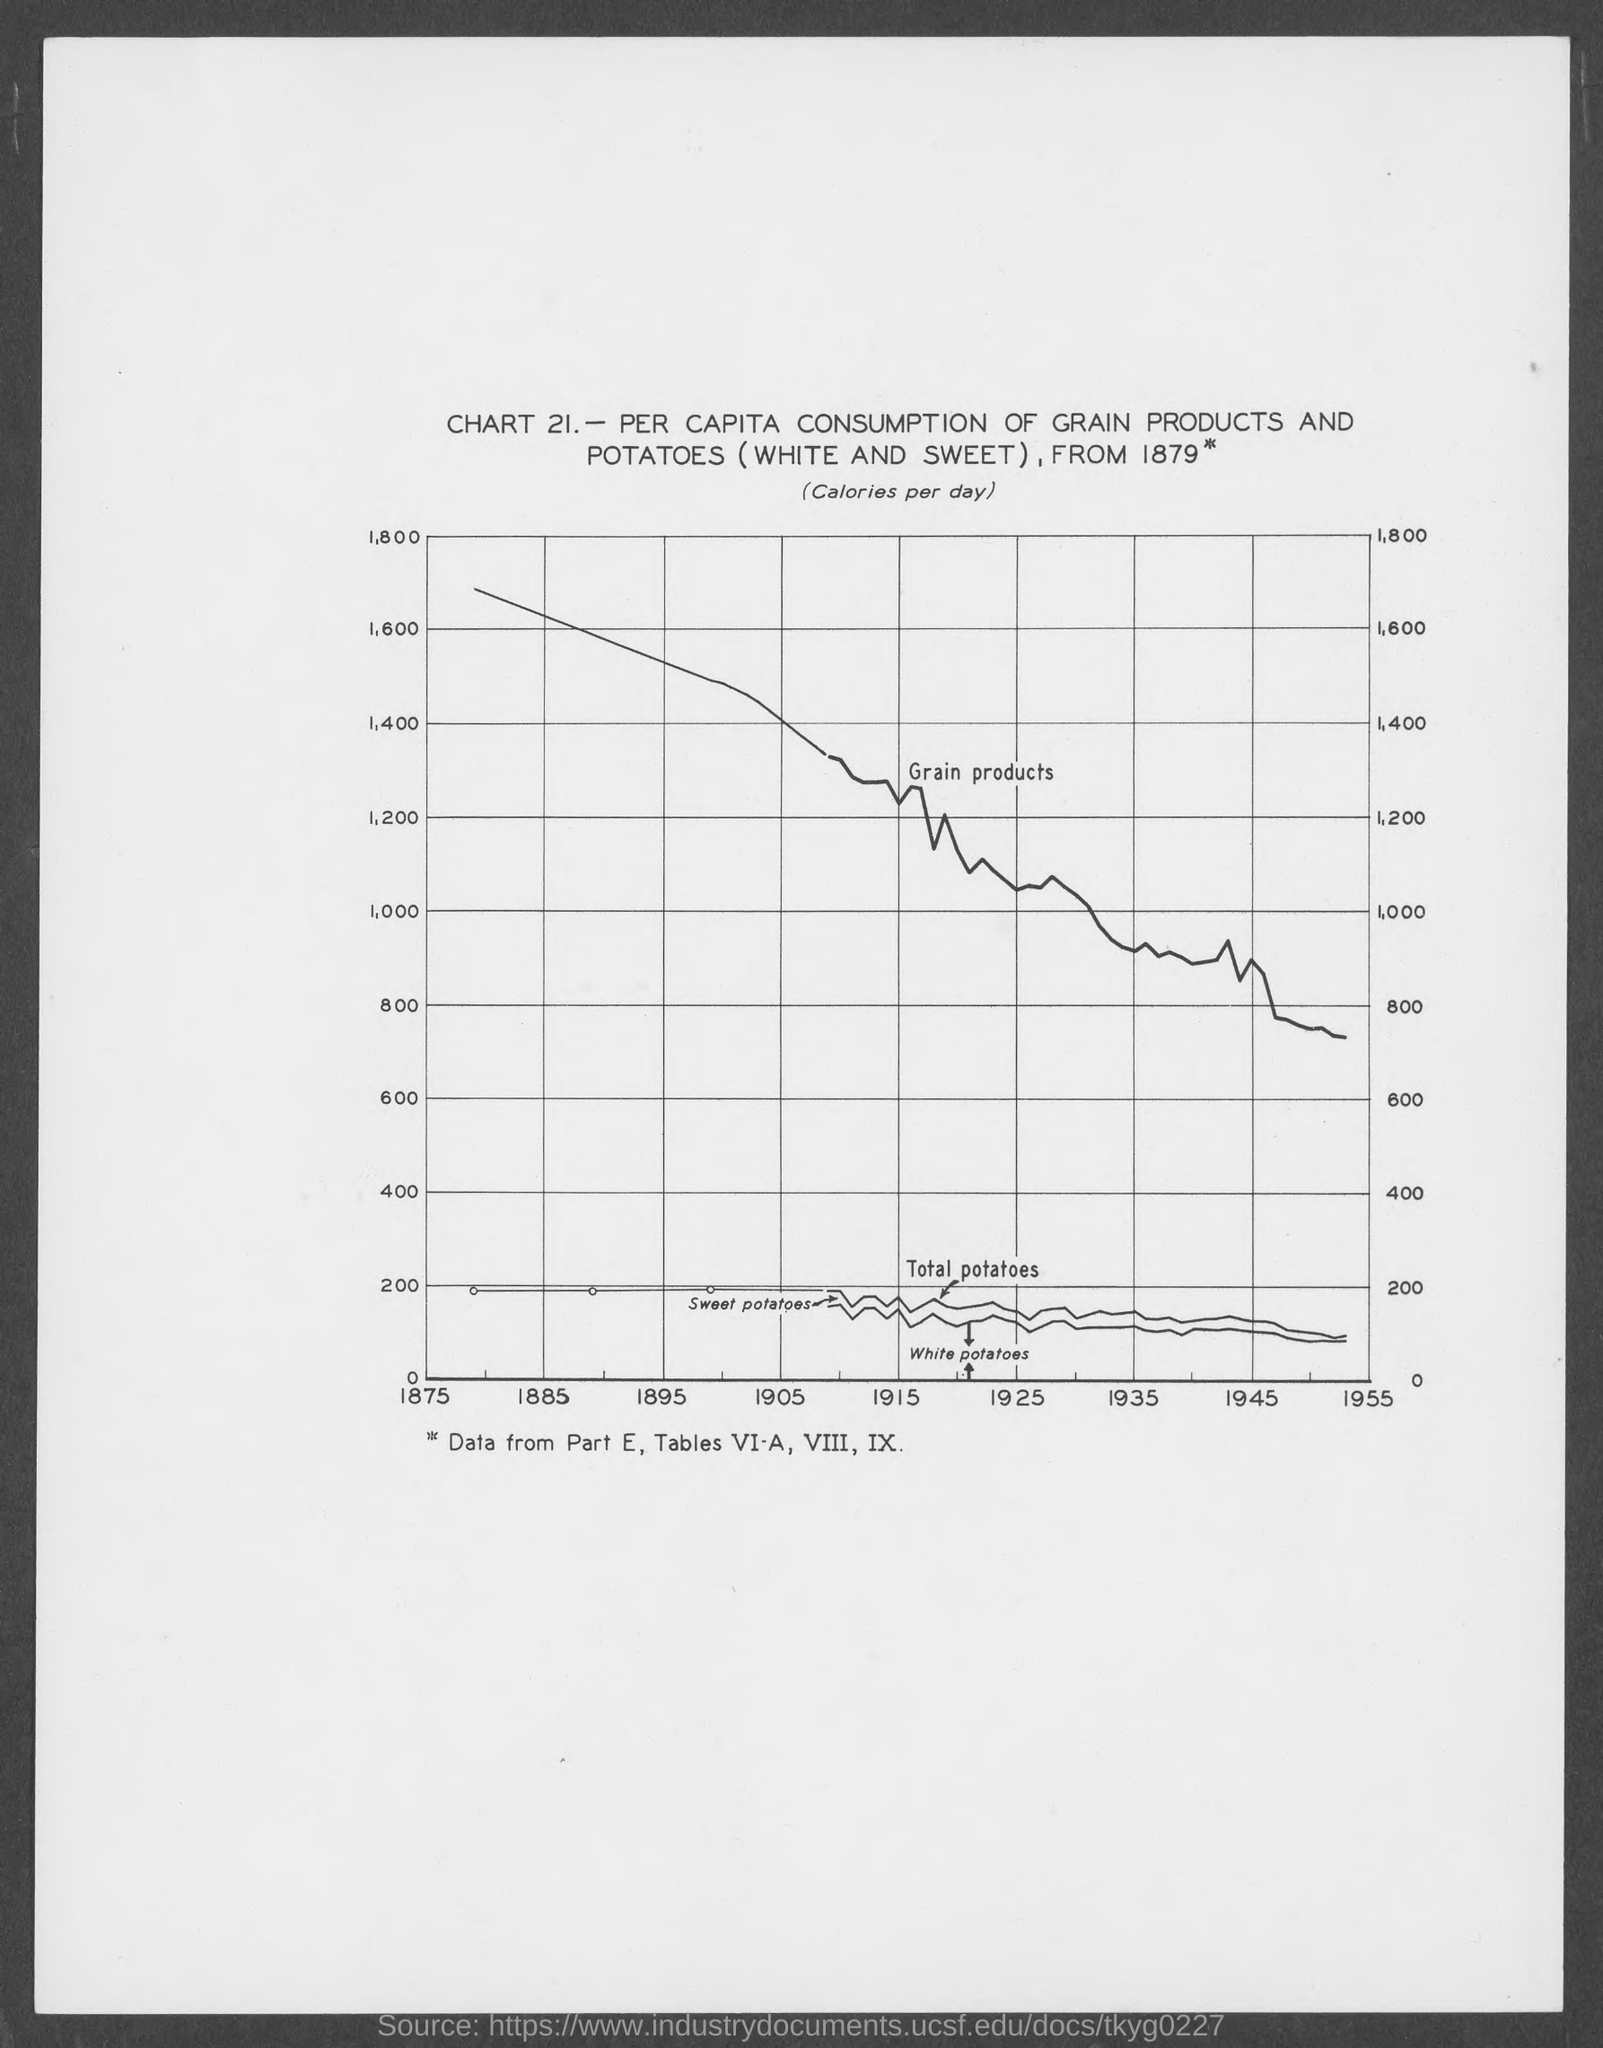What is the chart no.?
Ensure brevity in your answer.  21. 